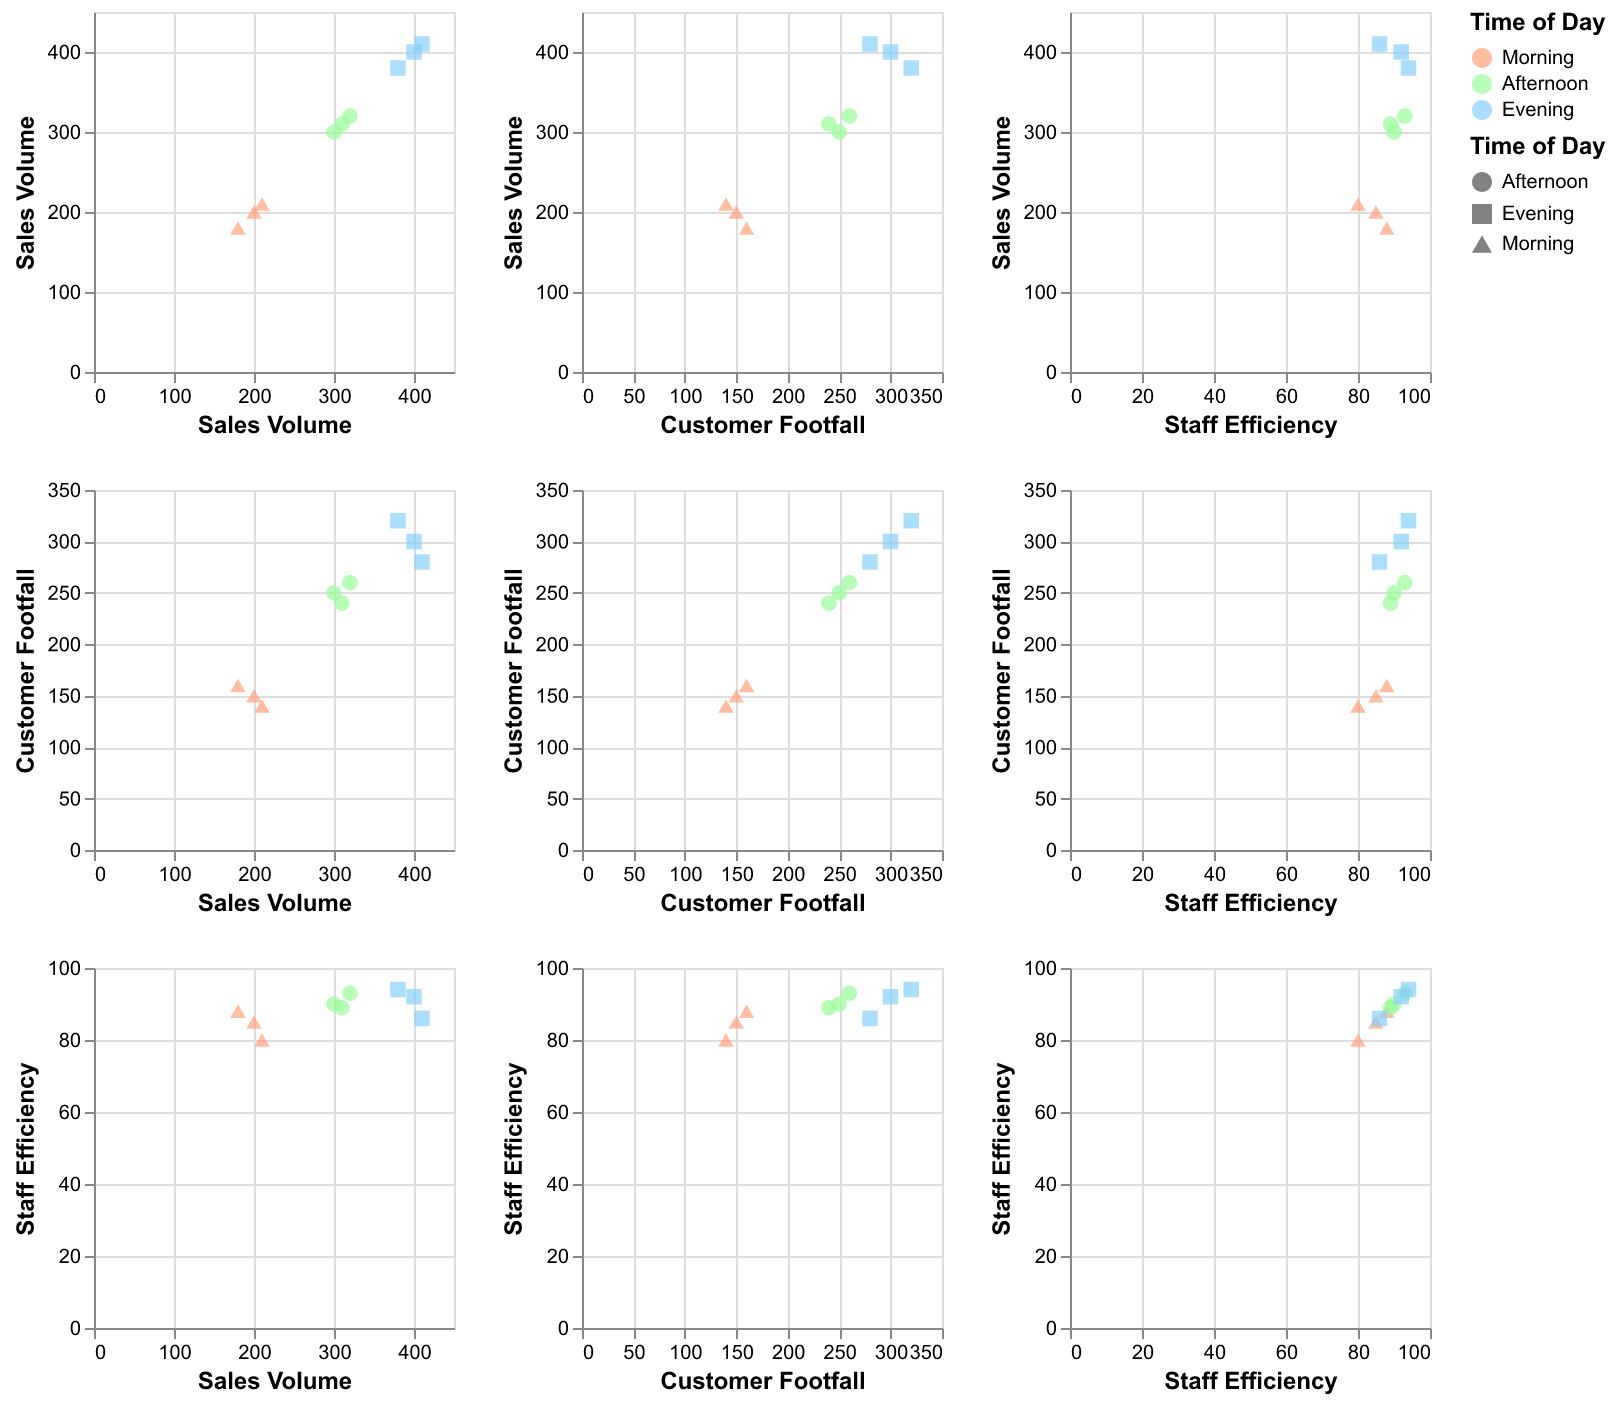How many data points are represented in the scatter plot matrix? From the given dataset, each row represents a data point. There are 9 rows in the data. Hence, there are 9 data points in the scatter plot matrix.
Answer: 9 What color represents "Afternoon" in the scatter plot matrix? The legend or color scale in the figure indicates that "Afternoon" is represented by the greenish color which matches "#98FB98".
Answer: Greenish How many data points belong to the "Evening" time of day? By checking the dataset, there are three rows where the "Time of Day" is "Evening". Thus, there are 3 data points for the "Evening" period in the scatter plot matrix.
Answer: 3 Which time of day generally seems to have higher Sales Volume? From the scatter plot matrix, the points representing the evening time of day (blue) tend to have higher sales volumes compared to morning and afternoon periods. By visually assessing the data points, evening has the highest sales values like 400, 380, and 410.
Answer: Evening What is the relationship between Customer Footfall and Sales Volume across different times of the day? Observing the scatter plots where Customer Footfall is plotted against Sales Volume, it can be noticed that as Customer Footfall increases, Sales Volume generally increases for each time of day. This trend is visible across Morning, Afternoon, and Evening periods.
Answer: Positive Relationship Comparing the three time periods, which one has the highest Staff Efficiency values? By examining the scatter plot matrix, it is visible that the "Afternoon" points (green) show the highest Staff Efficiency values, reaching up to 93, compared to Morning and Evening.
Answer: Afternoon Is there any time of day when Customer Footfall is lowest? In the scatter plots, the morning period (orange) generally shows lower Customer Footfall values compared to Afternoon and Evening. Values like 140 and 150 are seen for the morning period.
Answer: Morning Which time of day has the largest variability in Customer Footfall? Visual inspection of the scatter plot matrix shows that the Evening period (blue) has the points spread out over a larger range of Customer Footfall values, from 280 to 320, suggesting higher variability.
Answer: Evening Is there any visible correlation between Staff Efficiency and Sales Volume in the matrix? Observing the scatter plots of Staff Efficiency versus Sales Volume, there doesn't appear to be a strong visible correlation. The points are fairly dispersed, indicating little to no strong correlation.
Answer: No strong correlation Which data point has the highest Sales Volume, and what time of day does it belong to? In the scatter plot matrix, the data point with the highest Sales Volume is 410. By referring to the dataset, it corresponds to the "Evening" time of day.
Answer: 410, Evening 